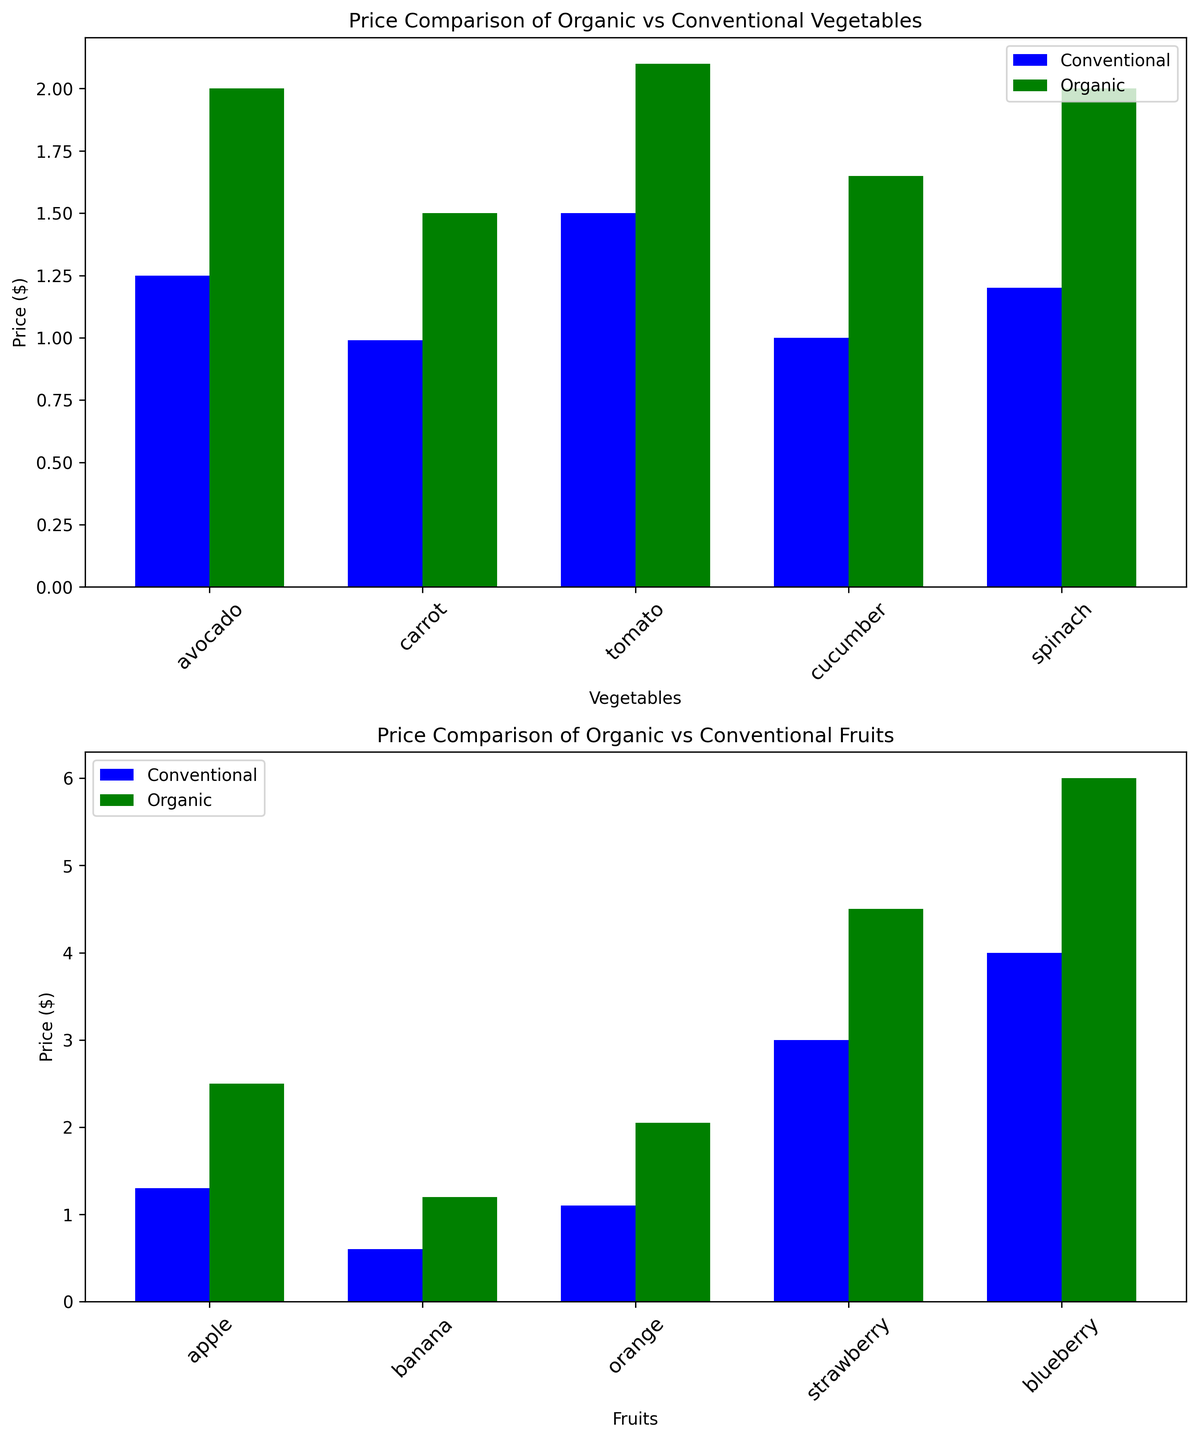Which vegetable has the highest price difference between organic and conventional? The highest price difference is for spinach, which is $2.00 (organic) - $1.20 (conventional) = $0.80.
Answer: Spinach Which fruit shows the smallest price difference between organic and conventional? The smallest price difference is for the banana, which is $1.20 (organic) - $0.60 (conventional) = $0.60.
Answer: Banana What is the average price of organic vegetables? Sum the prices of organic avocados, carrots, tomatoes, cucumbers, and spinach and divide by the number of items: (2.00 + 1.50 + 2.10 + 1.65 + 2.00) / 5 = 9.25 / 5 = 1.85.
Answer: 1.85 Which category, vegetables or fruits, has the largest overall price increase when buying organic instead of conventional? Sum the price increases for each produce in each category and compare: Vegetables: (2.00-1.25) + (1.50-0.99) + (2.10-1.50) + (1.65-1.00) + (2.00-1.20) = 0.75 + 0.51 + 0.60 + 0.65 + 0.80 = 3.31. Fruits: (2.50-1.30) + (1.20-0.60) + (2.05-1.10) + (4.50-3.00) + (6.00-4.00) = 1.20 + 0.60 + 0.95 + 1.50 + 2.00 = 6.25. Fruits have a larger overall price increase.
Answer: Fruits What is the median price of conventional fruits? List the conventional fruit prices and find the median: $0.60, $1.10, $1.30, $3.00, $4.00. The median (middle value) of these prices is $1.30.
Answer: 1.30 Which vegetable has the lowest conventional price, and what is it? The lowest conventional price is for the carrot, which is $0.99.
Answer: Carrot ($0.99) Are there any fruits where the conventional price is higher than $2.00? By comparing the conventional prices listed for all fruits, only the strawberry and blueberry have a conventional price higher than $2.00.
Answer: Strawberry, Blueberry 